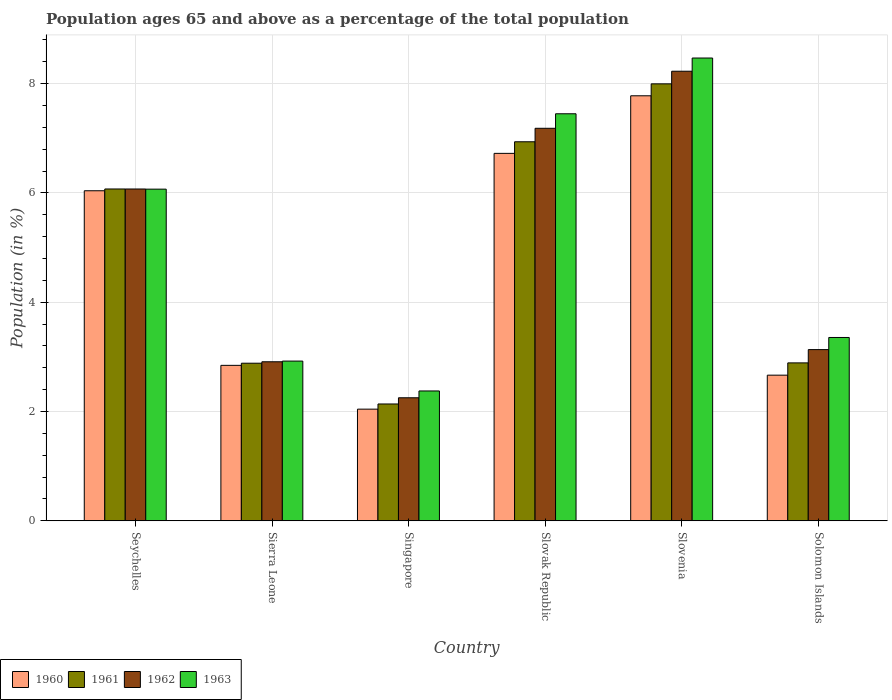How many different coloured bars are there?
Your answer should be compact. 4. How many groups of bars are there?
Provide a succinct answer. 6. Are the number of bars per tick equal to the number of legend labels?
Make the answer very short. Yes. How many bars are there on the 4th tick from the left?
Offer a terse response. 4. What is the label of the 6th group of bars from the left?
Give a very brief answer. Solomon Islands. In how many cases, is the number of bars for a given country not equal to the number of legend labels?
Your answer should be very brief. 0. What is the percentage of the population ages 65 and above in 1962 in Slovenia?
Your response must be concise. 8.23. Across all countries, what is the maximum percentage of the population ages 65 and above in 1962?
Provide a short and direct response. 8.23. Across all countries, what is the minimum percentage of the population ages 65 and above in 1963?
Make the answer very short. 2.38. In which country was the percentage of the population ages 65 and above in 1961 maximum?
Provide a succinct answer. Slovenia. In which country was the percentage of the population ages 65 and above in 1963 minimum?
Your answer should be very brief. Singapore. What is the total percentage of the population ages 65 and above in 1962 in the graph?
Your answer should be very brief. 29.78. What is the difference between the percentage of the population ages 65 and above in 1961 in Sierra Leone and that in Slovak Republic?
Provide a short and direct response. -4.05. What is the difference between the percentage of the population ages 65 and above in 1962 in Solomon Islands and the percentage of the population ages 65 and above in 1960 in Seychelles?
Offer a very short reply. -2.91. What is the average percentage of the population ages 65 and above in 1961 per country?
Offer a very short reply. 4.82. What is the difference between the percentage of the population ages 65 and above of/in 1963 and percentage of the population ages 65 and above of/in 1961 in Seychelles?
Keep it short and to the point. -0. In how many countries, is the percentage of the population ages 65 and above in 1962 greater than 1.6?
Give a very brief answer. 6. What is the ratio of the percentage of the population ages 65 and above in 1961 in Sierra Leone to that in Slovak Republic?
Make the answer very short. 0.42. Is the percentage of the population ages 65 and above in 1962 in Slovak Republic less than that in Slovenia?
Your response must be concise. Yes. Is the difference between the percentage of the population ages 65 and above in 1963 in Singapore and Slovak Republic greater than the difference between the percentage of the population ages 65 and above in 1961 in Singapore and Slovak Republic?
Give a very brief answer. No. What is the difference between the highest and the second highest percentage of the population ages 65 and above in 1963?
Ensure brevity in your answer.  2.4. What is the difference between the highest and the lowest percentage of the population ages 65 and above in 1961?
Your answer should be very brief. 5.86. Is the sum of the percentage of the population ages 65 and above in 1960 in Seychelles and Singapore greater than the maximum percentage of the population ages 65 and above in 1961 across all countries?
Offer a very short reply. Yes. Is it the case that in every country, the sum of the percentage of the population ages 65 and above in 1963 and percentage of the population ages 65 and above in 1960 is greater than the sum of percentage of the population ages 65 and above in 1962 and percentage of the population ages 65 and above in 1961?
Your answer should be compact. No. How many bars are there?
Your response must be concise. 24. Are all the bars in the graph horizontal?
Your response must be concise. No. How many countries are there in the graph?
Give a very brief answer. 6. Are the values on the major ticks of Y-axis written in scientific E-notation?
Your response must be concise. No. Does the graph contain any zero values?
Offer a terse response. No. Where does the legend appear in the graph?
Provide a succinct answer. Bottom left. How are the legend labels stacked?
Provide a short and direct response. Horizontal. What is the title of the graph?
Offer a terse response. Population ages 65 and above as a percentage of the total population. Does "1968" appear as one of the legend labels in the graph?
Keep it short and to the point. No. What is the label or title of the Y-axis?
Offer a terse response. Population (in %). What is the Population (in %) in 1960 in Seychelles?
Ensure brevity in your answer.  6.04. What is the Population (in %) of 1961 in Seychelles?
Make the answer very short. 6.07. What is the Population (in %) in 1962 in Seychelles?
Your response must be concise. 6.07. What is the Population (in %) of 1963 in Seychelles?
Make the answer very short. 6.07. What is the Population (in %) in 1960 in Sierra Leone?
Make the answer very short. 2.85. What is the Population (in %) in 1961 in Sierra Leone?
Keep it short and to the point. 2.88. What is the Population (in %) of 1962 in Sierra Leone?
Your answer should be compact. 2.91. What is the Population (in %) of 1963 in Sierra Leone?
Offer a terse response. 2.92. What is the Population (in %) in 1960 in Singapore?
Provide a succinct answer. 2.04. What is the Population (in %) in 1961 in Singapore?
Give a very brief answer. 2.14. What is the Population (in %) in 1962 in Singapore?
Keep it short and to the point. 2.25. What is the Population (in %) of 1963 in Singapore?
Make the answer very short. 2.38. What is the Population (in %) in 1960 in Slovak Republic?
Offer a terse response. 6.72. What is the Population (in %) in 1961 in Slovak Republic?
Offer a very short reply. 6.94. What is the Population (in %) of 1962 in Slovak Republic?
Ensure brevity in your answer.  7.18. What is the Population (in %) in 1963 in Slovak Republic?
Your answer should be very brief. 7.45. What is the Population (in %) of 1960 in Slovenia?
Your answer should be compact. 7.78. What is the Population (in %) in 1961 in Slovenia?
Make the answer very short. 8. What is the Population (in %) in 1962 in Slovenia?
Your answer should be very brief. 8.23. What is the Population (in %) of 1963 in Slovenia?
Provide a short and direct response. 8.47. What is the Population (in %) of 1960 in Solomon Islands?
Your answer should be very brief. 2.67. What is the Population (in %) of 1961 in Solomon Islands?
Provide a short and direct response. 2.89. What is the Population (in %) in 1962 in Solomon Islands?
Make the answer very short. 3.13. What is the Population (in %) in 1963 in Solomon Islands?
Your response must be concise. 3.36. Across all countries, what is the maximum Population (in %) in 1960?
Your response must be concise. 7.78. Across all countries, what is the maximum Population (in %) of 1961?
Give a very brief answer. 8. Across all countries, what is the maximum Population (in %) in 1962?
Your response must be concise. 8.23. Across all countries, what is the maximum Population (in %) of 1963?
Your answer should be compact. 8.47. Across all countries, what is the minimum Population (in %) of 1960?
Ensure brevity in your answer.  2.04. Across all countries, what is the minimum Population (in %) of 1961?
Give a very brief answer. 2.14. Across all countries, what is the minimum Population (in %) in 1962?
Your answer should be compact. 2.25. Across all countries, what is the minimum Population (in %) of 1963?
Provide a short and direct response. 2.38. What is the total Population (in %) of 1960 in the graph?
Provide a short and direct response. 28.1. What is the total Population (in %) in 1961 in the graph?
Your response must be concise. 28.92. What is the total Population (in %) in 1962 in the graph?
Your answer should be very brief. 29.78. What is the total Population (in %) in 1963 in the graph?
Ensure brevity in your answer.  30.64. What is the difference between the Population (in %) of 1960 in Seychelles and that in Sierra Leone?
Offer a very short reply. 3.19. What is the difference between the Population (in %) in 1961 in Seychelles and that in Sierra Leone?
Your response must be concise. 3.19. What is the difference between the Population (in %) in 1962 in Seychelles and that in Sierra Leone?
Give a very brief answer. 3.16. What is the difference between the Population (in %) of 1963 in Seychelles and that in Sierra Leone?
Ensure brevity in your answer.  3.15. What is the difference between the Population (in %) of 1960 in Seychelles and that in Singapore?
Provide a succinct answer. 4. What is the difference between the Population (in %) of 1961 in Seychelles and that in Singapore?
Ensure brevity in your answer.  3.93. What is the difference between the Population (in %) in 1962 in Seychelles and that in Singapore?
Ensure brevity in your answer.  3.82. What is the difference between the Population (in %) in 1963 in Seychelles and that in Singapore?
Your answer should be compact. 3.69. What is the difference between the Population (in %) of 1960 in Seychelles and that in Slovak Republic?
Make the answer very short. -0.68. What is the difference between the Population (in %) in 1961 in Seychelles and that in Slovak Republic?
Your answer should be very brief. -0.86. What is the difference between the Population (in %) of 1962 in Seychelles and that in Slovak Republic?
Provide a succinct answer. -1.11. What is the difference between the Population (in %) in 1963 in Seychelles and that in Slovak Republic?
Offer a very short reply. -1.38. What is the difference between the Population (in %) of 1960 in Seychelles and that in Slovenia?
Provide a short and direct response. -1.74. What is the difference between the Population (in %) of 1961 in Seychelles and that in Slovenia?
Make the answer very short. -1.92. What is the difference between the Population (in %) of 1962 in Seychelles and that in Slovenia?
Give a very brief answer. -2.16. What is the difference between the Population (in %) of 1963 in Seychelles and that in Slovenia?
Your response must be concise. -2.4. What is the difference between the Population (in %) of 1960 in Seychelles and that in Solomon Islands?
Your answer should be very brief. 3.37. What is the difference between the Population (in %) in 1961 in Seychelles and that in Solomon Islands?
Provide a succinct answer. 3.18. What is the difference between the Population (in %) in 1962 in Seychelles and that in Solomon Islands?
Your response must be concise. 2.94. What is the difference between the Population (in %) in 1963 in Seychelles and that in Solomon Islands?
Make the answer very short. 2.71. What is the difference between the Population (in %) in 1960 in Sierra Leone and that in Singapore?
Provide a succinct answer. 0.8. What is the difference between the Population (in %) of 1961 in Sierra Leone and that in Singapore?
Your answer should be compact. 0.75. What is the difference between the Population (in %) of 1962 in Sierra Leone and that in Singapore?
Your response must be concise. 0.66. What is the difference between the Population (in %) of 1963 in Sierra Leone and that in Singapore?
Offer a very short reply. 0.55. What is the difference between the Population (in %) in 1960 in Sierra Leone and that in Slovak Republic?
Keep it short and to the point. -3.88. What is the difference between the Population (in %) in 1961 in Sierra Leone and that in Slovak Republic?
Make the answer very short. -4.05. What is the difference between the Population (in %) in 1962 in Sierra Leone and that in Slovak Republic?
Offer a very short reply. -4.27. What is the difference between the Population (in %) in 1963 in Sierra Leone and that in Slovak Republic?
Offer a very short reply. -4.53. What is the difference between the Population (in %) in 1960 in Sierra Leone and that in Slovenia?
Provide a short and direct response. -4.93. What is the difference between the Population (in %) in 1961 in Sierra Leone and that in Slovenia?
Offer a terse response. -5.11. What is the difference between the Population (in %) of 1962 in Sierra Leone and that in Slovenia?
Make the answer very short. -5.32. What is the difference between the Population (in %) of 1963 in Sierra Leone and that in Slovenia?
Keep it short and to the point. -5.55. What is the difference between the Population (in %) in 1960 in Sierra Leone and that in Solomon Islands?
Provide a succinct answer. 0.18. What is the difference between the Population (in %) of 1961 in Sierra Leone and that in Solomon Islands?
Your answer should be very brief. -0.01. What is the difference between the Population (in %) of 1962 in Sierra Leone and that in Solomon Islands?
Your answer should be compact. -0.22. What is the difference between the Population (in %) of 1963 in Sierra Leone and that in Solomon Islands?
Your answer should be compact. -0.43. What is the difference between the Population (in %) in 1960 in Singapore and that in Slovak Republic?
Give a very brief answer. -4.68. What is the difference between the Population (in %) in 1961 in Singapore and that in Slovak Republic?
Your response must be concise. -4.8. What is the difference between the Population (in %) of 1962 in Singapore and that in Slovak Republic?
Offer a terse response. -4.93. What is the difference between the Population (in %) of 1963 in Singapore and that in Slovak Republic?
Your response must be concise. -5.07. What is the difference between the Population (in %) of 1960 in Singapore and that in Slovenia?
Offer a terse response. -5.73. What is the difference between the Population (in %) in 1961 in Singapore and that in Slovenia?
Offer a very short reply. -5.86. What is the difference between the Population (in %) of 1962 in Singapore and that in Slovenia?
Provide a succinct answer. -5.98. What is the difference between the Population (in %) of 1963 in Singapore and that in Slovenia?
Offer a terse response. -6.09. What is the difference between the Population (in %) in 1960 in Singapore and that in Solomon Islands?
Your answer should be compact. -0.62. What is the difference between the Population (in %) of 1961 in Singapore and that in Solomon Islands?
Ensure brevity in your answer.  -0.75. What is the difference between the Population (in %) of 1962 in Singapore and that in Solomon Islands?
Your answer should be compact. -0.88. What is the difference between the Population (in %) in 1963 in Singapore and that in Solomon Islands?
Provide a succinct answer. -0.98. What is the difference between the Population (in %) in 1960 in Slovak Republic and that in Slovenia?
Your answer should be very brief. -1.05. What is the difference between the Population (in %) in 1961 in Slovak Republic and that in Slovenia?
Your response must be concise. -1.06. What is the difference between the Population (in %) in 1962 in Slovak Republic and that in Slovenia?
Keep it short and to the point. -1.04. What is the difference between the Population (in %) of 1963 in Slovak Republic and that in Slovenia?
Offer a very short reply. -1.02. What is the difference between the Population (in %) in 1960 in Slovak Republic and that in Solomon Islands?
Provide a short and direct response. 4.06. What is the difference between the Population (in %) in 1961 in Slovak Republic and that in Solomon Islands?
Keep it short and to the point. 4.05. What is the difference between the Population (in %) of 1962 in Slovak Republic and that in Solomon Islands?
Provide a succinct answer. 4.05. What is the difference between the Population (in %) of 1963 in Slovak Republic and that in Solomon Islands?
Offer a terse response. 4.09. What is the difference between the Population (in %) of 1960 in Slovenia and that in Solomon Islands?
Your answer should be very brief. 5.11. What is the difference between the Population (in %) of 1961 in Slovenia and that in Solomon Islands?
Offer a terse response. 5.11. What is the difference between the Population (in %) in 1962 in Slovenia and that in Solomon Islands?
Provide a short and direct response. 5.09. What is the difference between the Population (in %) in 1963 in Slovenia and that in Solomon Islands?
Ensure brevity in your answer.  5.11. What is the difference between the Population (in %) of 1960 in Seychelles and the Population (in %) of 1961 in Sierra Leone?
Your answer should be compact. 3.16. What is the difference between the Population (in %) of 1960 in Seychelles and the Population (in %) of 1962 in Sierra Leone?
Your answer should be compact. 3.13. What is the difference between the Population (in %) of 1960 in Seychelles and the Population (in %) of 1963 in Sierra Leone?
Give a very brief answer. 3.12. What is the difference between the Population (in %) of 1961 in Seychelles and the Population (in %) of 1962 in Sierra Leone?
Give a very brief answer. 3.16. What is the difference between the Population (in %) in 1961 in Seychelles and the Population (in %) in 1963 in Sierra Leone?
Keep it short and to the point. 3.15. What is the difference between the Population (in %) of 1962 in Seychelles and the Population (in %) of 1963 in Sierra Leone?
Ensure brevity in your answer.  3.15. What is the difference between the Population (in %) of 1960 in Seychelles and the Population (in %) of 1961 in Singapore?
Make the answer very short. 3.9. What is the difference between the Population (in %) in 1960 in Seychelles and the Population (in %) in 1962 in Singapore?
Provide a short and direct response. 3.79. What is the difference between the Population (in %) in 1960 in Seychelles and the Population (in %) in 1963 in Singapore?
Your answer should be very brief. 3.66. What is the difference between the Population (in %) in 1961 in Seychelles and the Population (in %) in 1962 in Singapore?
Make the answer very short. 3.82. What is the difference between the Population (in %) of 1961 in Seychelles and the Population (in %) of 1963 in Singapore?
Offer a terse response. 3.7. What is the difference between the Population (in %) in 1962 in Seychelles and the Population (in %) in 1963 in Singapore?
Offer a very short reply. 3.7. What is the difference between the Population (in %) of 1960 in Seychelles and the Population (in %) of 1961 in Slovak Republic?
Your answer should be very brief. -0.9. What is the difference between the Population (in %) of 1960 in Seychelles and the Population (in %) of 1962 in Slovak Republic?
Offer a very short reply. -1.14. What is the difference between the Population (in %) in 1960 in Seychelles and the Population (in %) in 1963 in Slovak Republic?
Keep it short and to the point. -1.41. What is the difference between the Population (in %) in 1961 in Seychelles and the Population (in %) in 1962 in Slovak Republic?
Keep it short and to the point. -1.11. What is the difference between the Population (in %) of 1961 in Seychelles and the Population (in %) of 1963 in Slovak Republic?
Make the answer very short. -1.38. What is the difference between the Population (in %) of 1962 in Seychelles and the Population (in %) of 1963 in Slovak Republic?
Your answer should be compact. -1.38. What is the difference between the Population (in %) in 1960 in Seychelles and the Population (in %) in 1961 in Slovenia?
Give a very brief answer. -1.96. What is the difference between the Population (in %) of 1960 in Seychelles and the Population (in %) of 1962 in Slovenia?
Ensure brevity in your answer.  -2.19. What is the difference between the Population (in %) in 1960 in Seychelles and the Population (in %) in 1963 in Slovenia?
Offer a terse response. -2.43. What is the difference between the Population (in %) in 1961 in Seychelles and the Population (in %) in 1962 in Slovenia?
Provide a succinct answer. -2.15. What is the difference between the Population (in %) of 1961 in Seychelles and the Population (in %) of 1963 in Slovenia?
Offer a very short reply. -2.4. What is the difference between the Population (in %) in 1962 in Seychelles and the Population (in %) in 1963 in Slovenia?
Make the answer very short. -2.4. What is the difference between the Population (in %) of 1960 in Seychelles and the Population (in %) of 1961 in Solomon Islands?
Provide a short and direct response. 3.15. What is the difference between the Population (in %) of 1960 in Seychelles and the Population (in %) of 1962 in Solomon Islands?
Provide a short and direct response. 2.91. What is the difference between the Population (in %) in 1960 in Seychelles and the Population (in %) in 1963 in Solomon Islands?
Ensure brevity in your answer.  2.68. What is the difference between the Population (in %) in 1961 in Seychelles and the Population (in %) in 1962 in Solomon Islands?
Your answer should be very brief. 2.94. What is the difference between the Population (in %) of 1961 in Seychelles and the Population (in %) of 1963 in Solomon Islands?
Provide a short and direct response. 2.72. What is the difference between the Population (in %) in 1962 in Seychelles and the Population (in %) in 1963 in Solomon Islands?
Offer a terse response. 2.72. What is the difference between the Population (in %) in 1960 in Sierra Leone and the Population (in %) in 1961 in Singapore?
Your response must be concise. 0.71. What is the difference between the Population (in %) of 1960 in Sierra Leone and the Population (in %) of 1962 in Singapore?
Offer a terse response. 0.59. What is the difference between the Population (in %) in 1960 in Sierra Leone and the Population (in %) in 1963 in Singapore?
Your answer should be compact. 0.47. What is the difference between the Population (in %) in 1961 in Sierra Leone and the Population (in %) in 1962 in Singapore?
Your answer should be very brief. 0.63. What is the difference between the Population (in %) of 1961 in Sierra Leone and the Population (in %) of 1963 in Singapore?
Offer a very short reply. 0.51. What is the difference between the Population (in %) of 1962 in Sierra Leone and the Population (in %) of 1963 in Singapore?
Offer a terse response. 0.53. What is the difference between the Population (in %) of 1960 in Sierra Leone and the Population (in %) of 1961 in Slovak Republic?
Give a very brief answer. -4.09. What is the difference between the Population (in %) in 1960 in Sierra Leone and the Population (in %) in 1962 in Slovak Republic?
Keep it short and to the point. -4.34. What is the difference between the Population (in %) of 1960 in Sierra Leone and the Population (in %) of 1963 in Slovak Republic?
Keep it short and to the point. -4.6. What is the difference between the Population (in %) in 1961 in Sierra Leone and the Population (in %) in 1962 in Slovak Republic?
Your answer should be compact. -4.3. What is the difference between the Population (in %) in 1961 in Sierra Leone and the Population (in %) in 1963 in Slovak Republic?
Ensure brevity in your answer.  -4.56. What is the difference between the Population (in %) in 1962 in Sierra Leone and the Population (in %) in 1963 in Slovak Republic?
Provide a succinct answer. -4.54. What is the difference between the Population (in %) of 1960 in Sierra Leone and the Population (in %) of 1961 in Slovenia?
Make the answer very short. -5.15. What is the difference between the Population (in %) in 1960 in Sierra Leone and the Population (in %) in 1962 in Slovenia?
Your answer should be compact. -5.38. What is the difference between the Population (in %) in 1960 in Sierra Leone and the Population (in %) in 1963 in Slovenia?
Make the answer very short. -5.62. What is the difference between the Population (in %) of 1961 in Sierra Leone and the Population (in %) of 1962 in Slovenia?
Ensure brevity in your answer.  -5.34. What is the difference between the Population (in %) of 1961 in Sierra Leone and the Population (in %) of 1963 in Slovenia?
Offer a terse response. -5.58. What is the difference between the Population (in %) in 1962 in Sierra Leone and the Population (in %) in 1963 in Slovenia?
Ensure brevity in your answer.  -5.56. What is the difference between the Population (in %) of 1960 in Sierra Leone and the Population (in %) of 1961 in Solomon Islands?
Keep it short and to the point. -0.05. What is the difference between the Population (in %) of 1960 in Sierra Leone and the Population (in %) of 1962 in Solomon Islands?
Your response must be concise. -0.29. What is the difference between the Population (in %) in 1960 in Sierra Leone and the Population (in %) in 1963 in Solomon Islands?
Your answer should be compact. -0.51. What is the difference between the Population (in %) of 1961 in Sierra Leone and the Population (in %) of 1962 in Solomon Islands?
Make the answer very short. -0.25. What is the difference between the Population (in %) of 1961 in Sierra Leone and the Population (in %) of 1963 in Solomon Islands?
Offer a very short reply. -0.47. What is the difference between the Population (in %) in 1962 in Sierra Leone and the Population (in %) in 1963 in Solomon Islands?
Your response must be concise. -0.44. What is the difference between the Population (in %) in 1960 in Singapore and the Population (in %) in 1961 in Slovak Republic?
Your answer should be compact. -4.89. What is the difference between the Population (in %) in 1960 in Singapore and the Population (in %) in 1962 in Slovak Republic?
Keep it short and to the point. -5.14. What is the difference between the Population (in %) in 1960 in Singapore and the Population (in %) in 1963 in Slovak Republic?
Ensure brevity in your answer.  -5.41. What is the difference between the Population (in %) of 1961 in Singapore and the Population (in %) of 1962 in Slovak Republic?
Make the answer very short. -5.05. What is the difference between the Population (in %) of 1961 in Singapore and the Population (in %) of 1963 in Slovak Republic?
Make the answer very short. -5.31. What is the difference between the Population (in %) of 1962 in Singapore and the Population (in %) of 1963 in Slovak Republic?
Give a very brief answer. -5.2. What is the difference between the Population (in %) in 1960 in Singapore and the Population (in %) in 1961 in Slovenia?
Give a very brief answer. -5.95. What is the difference between the Population (in %) in 1960 in Singapore and the Population (in %) in 1962 in Slovenia?
Your answer should be compact. -6.18. What is the difference between the Population (in %) in 1960 in Singapore and the Population (in %) in 1963 in Slovenia?
Keep it short and to the point. -6.43. What is the difference between the Population (in %) in 1961 in Singapore and the Population (in %) in 1962 in Slovenia?
Offer a terse response. -6.09. What is the difference between the Population (in %) of 1961 in Singapore and the Population (in %) of 1963 in Slovenia?
Your response must be concise. -6.33. What is the difference between the Population (in %) of 1962 in Singapore and the Population (in %) of 1963 in Slovenia?
Offer a terse response. -6.22. What is the difference between the Population (in %) of 1960 in Singapore and the Population (in %) of 1961 in Solomon Islands?
Your answer should be compact. -0.85. What is the difference between the Population (in %) of 1960 in Singapore and the Population (in %) of 1962 in Solomon Islands?
Your answer should be compact. -1.09. What is the difference between the Population (in %) in 1960 in Singapore and the Population (in %) in 1963 in Solomon Islands?
Offer a very short reply. -1.31. What is the difference between the Population (in %) in 1961 in Singapore and the Population (in %) in 1962 in Solomon Islands?
Ensure brevity in your answer.  -1. What is the difference between the Population (in %) of 1961 in Singapore and the Population (in %) of 1963 in Solomon Islands?
Your answer should be very brief. -1.22. What is the difference between the Population (in %) of 1962 in Singapore and the Population (in %) of 1963 in Solomon Islands?
Make the answer very short. -1.1. What is the difference between the Population (in %) in 1960 in Slovak Republic and the Population (in %) in 1961 in Slovenia?
Offer a terse response. -1.27. What is the difference between the Population (in %) in 1960 in Slovak Republic and the Population (in %) in 1962 in Slovenia?
Your answer should be compact. -1.5. What is the difference between the Population (in %) of 1960 in Slovak Republic and the Population (in %) of 1963 in Slovenia?
Give a very brief answer. -1.74. What is the difference between the Population (in %) of 1961 in Slovak Republic and the Population (in %) of 1962 in Slovenia?
Your response must be concise. -1.29. What is the difference between the Population (in %) of 1961 in Slovak Republic and the Population (in %) of 1963 in Slovenia?
Offer a terse response. -1.53. What is the difference between the Population (in %) in 1962 in Slovak Republic and the Population (in %) in 1963 in Slovenia?
Keep it short and to the point. -1.29. What is the difference between the Population (in %) of 1960 in Slovak Republic and the Population (in %) of 1961 in Solomon Islands?
Provide a succinct answer. 3.83. What is the difference between the Population (in %) in 1960 in Slovak Republic and the Population (in %) in 1962 in Solomon Islands?
Offer a very short reply. 3.59. What is the difference between the Population (in %) of 1960 in Slovak Republic and the Population (in %) of 1963 in Solomon Islands?
Your response must be concise. 3.37. What is the difference between the Population (in %) in 1961 in Slovak Republic and the Population (in %) in 1962 in Solomon Islands?
Your answer should be very brief. 3.8. What is the difference between the Population (in %) of 1961 in Slovak Republic and the Population (in %) of 1963 in Solomon Islands?
Your response must be concise. 3.58. What is the difference between the Population (in %) of 1962 in Slovak Republic and the Population (in %) of 1963 in Solomon Islands?
Give a very brief answer. 3.83. What is the difference between the Population (in %) in 1960 in Slovenia and the Population (in %) in 1961 in Solomon Islands?
Ensure brevity in your answer.  4.89. What is the difference between the Population (in %) in 1960 in Slovenia and the Population (in %) in 1962 in Solomon Islands?
Your response must be concise. 4.64. What is the difference between the Population (in %) in 1960 in Slovenia and the Population (in %) in 1963 in Solomon Islands?
Keep it short and to the point. 4.42. What is the difference between the Population (in %) of 1961 in Slovenia and the Population (in %) of 1962 in Solomon Islands?
Offer a very short reply. 4.86. What is the difference between the Population (in %) of 1961 in Slovenia and the Population (in %) of 1963 in Solomon Islands?
Provide a succinct answer. 4.64. What is the difference between the Population (in %) in 1962 in Slovenia and the Population (in %) in 1963 in Solomon Islands?
Offer a very short reply. 4.87. What is the average Population (in %) of 1960 per country?
Offer a very short reply. 4.68. What is the average Population (in %) of 1961 per country?
Your answer should be very brief. 4.82. What is the average Population (in %) in 1962 per country?
Offer a terse response. 4.96. What is the average Population (in %) in 1963 per country?
Your answer should be very brief. 5.11. What is the difference between the Population (in %) of 1960 and Population (in %) of 1961 in Seychelles?
Provide a succinct answer. -0.03. What is the difference between the Population (in %) of 1960 and Population (in %) of 1962 in Seychelles?
Give a very brief answer. -0.03. What is the difference between the Population (in %) of 1960 and Population (in %) of 1963 in Seychelles?
Ensure brevity in your answer.  -0.03. What is the difference between the Population (in %) in 1961 and Population (in %) in 1963 in Seychelles?
Your response must be concise. 0. What is the difference between the Population (in %) of 1962 and Population (in %) of 1963 in Seychelles?
Keep it short and to the point. 0. What is the difference between the Population (in %) in 1960 and Population (in %) in 1961 in Sierra Leone?
Ensure brevity in your answer.  -0.04. What is the difference between the Population (in %) in 1960 and Population (in %) in 1962 in Sierra Leone?
Offer a very short reply. -0.07. What is the difference between the Population (in %) in 1960 and Population (in %) in 1963 in Sierra Leone?
Give a very brief answer. -0.08. What is the difference between the Population (in %) in 1961 and Population (in %) in 1962 in Sierra Leone?
Your response must be concise. -0.03. What is the difference between the Population (in %) of 1961 and Population (in %) of 1963 in Sierra Leone?
Offer a very short reply. -0.04. What is the difference between the Population (in %) in 1962 and Population (in %) in 1963 in Sierra Leone?
Make the answer very short. -0.01. What is the difference between the Population (in %) in 1960 and Population (in %) in 1961 in Singapore?
Keep it short and to the point. -0.09. What is the difference between the Population (in %) of 1960 and Population (in %) of 1962 in Singapore?
Make the answer very short. -0.21. What is the difference between the Population (in %) of 1960 and Population (in %) of 1963 in Singapore?
Your answer should be compact. -0.33. What is the difference between the Population (in %) in 1961 and Population (in %) in 1962 in Singapore?
Give a very brief answer. -0.11. What is the difference between the Population (in %) of 1961 and Population (in %) of 1963 in Singapore?
Offer a terse response. -0.24. What is the difference between the Population (in %) in 1962 and Population (in %) in 1963 in Singapore?
Your answer should be compact. -0.12. What is the difference between the Population (in %) of 1960 and Population (in %) of 1961 in Slovak Republic?
Give a very brief answer. -0.21. What is the difference between the Population (in %) of 1960 and Population (in %) of 1962 in Slovak Republic?
Ensure brevity in your answer.  -0.46. What is the difference between the Population (in %) of 1960 and Population (in %) of 1963 in Slovak Republic?
Your answer should be very brief. -0.72. What is the difference between the Population (in %) in 1961 and Population (in %) in 1962 in Slovak Republic?
Give a very brief answer. -0.25. What is the difference between the Population (in %) of 1961 and Population (in %) of 1963 in Slovak Republic?
Make the answer very short. -0.51. What is the difference between the Population (in %) of 1962 and Population (in %) of 1963 in Slovak Republic?
Give a very brief answer. -0.27. What is the difference between the Population (in %) of 1960 and Population (in %) of 1961 in Slovenia?
Offer a terse response. -0.22. What is the difference between the Population (in %) of 1960 and Population (in %) of 1962 in Slovenia?
Your answer should be compact. -0.45. What is the difference between the Population (in %) in 1960 and Population (in %) in 1963 in Slovenia?
Ensure brevity in your answer.  -0.69. What is the difference between the Population (in %) in 1961 and Population (in %) in 1962 in Slovenia?
Keep it short and to the point. -0.23. What is the difference between the Population (in %) in 1961 and Population (in %) in 1963 in Slovenia?
Your answer should be compact. -0.47. What is the difference between the Population (in %) in 1962 and Population (in %) in 1963 in Slovenia?
Your answer should be compact. -0.24. What is the difference between the Population (in %) of 1960 and Population (in %) of 1961 in Solomon Islands?
Provide a short and direct response. -0.22. What is the difference between the Population (in %) in 1960 and Population (in %) in 1962 in Solomon Islands?
Keep it short and to the point. -0.47. What is the difference between the Population (in %) in 1960 and Population (in %) in 1963 in Solomon Islands?
Give a very brief answer. -0.69. What is the difference between the Population (in %) of 1961 and Population (in %) of 1962 in Solomon Islands?
Your answer should be very brief. -0.24. What is the difference between the Population (in %) of 1961 and Population (in %) of 1963 in Solomon Islands?
Offer a very short reply. -0.47. What is the difference between the Population (in %) in 1962 and Population (in %) in 1963 in Solomon Islands?
Make the answer very short. -0.22. What is the ratio of the Population (in %) of 1960 in Seychelles to that in Sierra Leone?
Offer a very short reply. 2.12. What is the ratio of the Population (in %) of 1961 in Seychelles to that in Sierra Leone?
Keep it short and to the point. 2.11. What is the ratio of the Population (in %) in 1962 in Seychelles to that in Sierra Leone?
Offer a very short reply. 2.09. What is the ratio of the Population (in %) in 1963 in Seychelles to that in Sierra Leone?
Provide a short and direct response. 2.08. What is the ratio of the Population (in %) in 1960 in Seychelles to that in Singapore?
Keep it short and to the point. 2.96. What is the ratio of the Population (in %) of 1961 in Seychelles to that in Singapore?
Keep it short and to the point. 2.84. What is the ratio of the Population (in %) in 1962 in Seychelles to that in Singapore?
Offer a very short reply. 2.7. What is the ratio of the Population (in %) of 1963 in Seychelles to that in Singapore?
Provide a short and direct response. 2.55. What is the ratio of the Population (in %) in 1960 in Seychelles to that in Slovak Republic?
Your response must be concise. 0.9. What is the ratio of the Population (in %) of 1961 in Seychelles to that in Slovak Republic?
Give a very brief answer. 0.88. What is the ratio of the Population (in %) in 1962 in Seychelles to that in Slovak Republic?
Provide a short and direct response. 0.85. What is the ratio of the Population (in %) of 1963 in Seychelles to that in Slovak Republic?
Provide a short and direct response. 0.81. What is the ratio of the Population (in %) in 1960 in Seychelles to that in Slovenia?
Offer a terse response. 0.78. What is the ratio of the Population (in %) of 1961 in Seychelles to that in Slovenia?
Provide a short and direct response. 0.76. What is the ratio of the Population (in %) of 1962 in Seychelles to that in Slovenia?
Offer a terse response. 0.74. What is the ratio of the Population (in %) of 1963 in Seychelles to that in Slovenia?
Provide a short and direct response. 0.72. What is the ratio of the Population (in %) in 1960 in Seychelles to that in Solomon Islands?
Make the answer very short. 2.27. What is the ratio of the Population (in %) in 1961 in Seychelles to that in Solomon Islands?
Offer a terse response. 2.1. What is the ratio of the Population (in %) of 1962 in Seychelles to that in Solomon Islands?
Provide a succinct answer. 1.94. What is the ratio of the Population (in %) of 1963 in Seychelles to that in Solomon Islands?
Keep it short and to the point. 1.81. What is the ratio of the Population (in %) in 1960 in Sierra Leone to that in Singapore?
Your answer should be very brief. 1.39. What is the ratio of the Population (in %) in 1961 in Sierra Leone to that in Singapore?
Your response must be concise. 1.35. What is the ratio of the Population (in %) in 1962 in Sierra Leone to that in Singapore?
Keep it short and to the point. 1.29. What is the ratio of the Population (in %) in 1963 in Sierra Leone to that in Singapore?
Keep it short and to the point. 1.23. What is the ratio of the Population (in %) in 1960 in Sierra Leone to that in Slovak Republic?
Give a very brief answer. 0.42. What is the ratio of the Population (in %) in 1961 in Sierra Leone to that in Slovak Republic?
Your answer should be compact. 0.42. What is the ratio of the Population (in %) in 1962 in Sierra Leone to that in Slovak Republic?
Provide a succinct answer. 0.41. What is the ratio of the Population (in %) in 1963 in Sierra Leone to that in Slovak Republic?
Your answer should be compact. 0.39. What is the ratio of the Population (in %) in 1960 in Sierra Leone to that in Slovenia?
Provide a short and direct response. 0.37. What is the ratio of the Population (in %) of 1961 in Sierra Leone to that in Slovenia?
Your response must be concise. 0.36. What is the ratio of the Population (in %) of 1962 in Sierra Leone to that in Slovenia?
Provide a succinct answer. 0.35. What is the ratio of the Population (in %) of 1963 in Sierra Leone to that in Slovenia?
Provide a succinct answer. 0.35. What is the ratio of the Population (in %) in 1960 in Sierra Leone to that in Solomon Islands?
Keep it short and to the point. 1.07. What is the ratio of the Population (in %) in 1962 in Sierra Leone to that in Solomon Islands?
Offer a terse response. 0.93. What is the ratio of the Population (in %) of 1963 in Sierra Leone to that in Solomon Islands?
Provide a succinct answer. 0.87. What is the ratio of the Population (in %) of 1960 in Singapore to that in Slovak Republic?
Give a very brief answer. 0.3. What is the ratio of the Population (in %) in 1961 in Singapore to that in Slovak Republic?
Give a very brief answer. 0.31. What is the ratio of the Population (in %) in 1962 in Singapore to that in Slovak Republic?
Make the answer very short. 0.31. What is the ratio of the Population (in %) in 1963 in Singapore to that in Slovak Republic?
Your response must be concise. 0.32. What is the ratio of the Population (in %) of 1960 in Singapore to that in Slovenia?
Make the answer very short. 0.26. What is the ratio of the Population (in %) of 1961 in Singapore to that in Slovenia?
Provide a succinct answer. 0.27. What is the ratio of the Population (in %) of 1962 in Singapore to that in Slovenia?
Offer a terse response. 0.27. What is the ratio of the Population (in %) in 1963 in Singapore to that in Slovenia?
Your response must be concise. 0.28. What is the ratio of the Population (in %) of 1960 in Singapore to that in Solomon Islands?
Provide a short and direct response. 0.77. What is the ratio of the Population (in %) of 1961 in Singapore to that in Solomon Islands?
Offer a terse response. 0.74. What is the ratio of the Population (in %) of 1962 in Singapore to that in Solomon Islands?
Offer a terse response. 0.72. What is the ratio of the Population (in %) in 1963 in Singapore to that in Solomon Islands?
Keep it short and to the point. 0.71. What is the ratio of the Population (in %) of 1960 in Slovak Republic to that in Slovenia?
Your response must be concise. 0.86. What is the ratio of the Population (in %) of 1961 in Slovak Republic to that in Slovenia?
Provide a short and direct response. 0.87. What is the ratio of the Population (in %) in 1962 in Slovak Republic to that in Slovenia?
Your answer should be compact. 0.87. What is the ratio of the Population (in %) in 1963 in Slovak Republic to that in Slovenia?
Give a very brief answer. 0.88. What is the ratio of the Population (in %) of 1960 in Slovak Republic to that in Solomon Islands?
Make the answer very short. 2.52. What is the ratio of the Population (in %) in 1961 in Slovak Republic to that in Solomon Islands?
Offer a very short reply. 2.4. What is the ratio of the Population (in %) in 1962 in Slovak Republic to that in Solomon Islands?
Give a very brief answer. 2.29. What is the ratio of the Population (in %) in 1963 in Slovak Republic to that in Solomon Islands?
Your response must be concise. 2.22. What is the ratio of the Population (in %) of 1960 in Slovenia to that in Solomon Islands?
Provide a short and direct response. 2.92. What is the ratio of the Population (in %) in 1961 in Slovenia to that in Solomon Islands?
Give a very brief answer. 2.77. What is the ratio of the Population (in %) of 1962 in Slovenia to that in Solomon Islands?
Provide a succinct answer. 2.63. What is the ratio of the Population (in %) of 1963 in Slovenia to that in Solomon Islands?
Offer a very short reply. 2.52. What is the difference between the highest and the second highest Population (in %) of 1960?
Provide a succinct answer. 1.05. What is the difference between the highest and the second highest Population (in %) in 1961?
Your answer should be compact. 1.06. What is the difference between the highest and the second highest Population (in %) of 1962?
Give a very brief answer. 1.04. What is the difference between the highest and the second highest Population (in %) of 1963?
Offer a very short reply. 1.02. What is the difference between the highest and the lowest Population (in %) in 1960?
Your response must be concise. 5.73. What is the difference between the highest and the lowest Population (in %) in 1961?
Your answer should be very brief. 5.86. What is the difference between the highest and the lowest Population (in %) of 1962?
Your answer should be compact. 5.98. What is the difference between the highest and the lowest Population (in %) in 1963?
Provide a succinct answer. 6.09. 